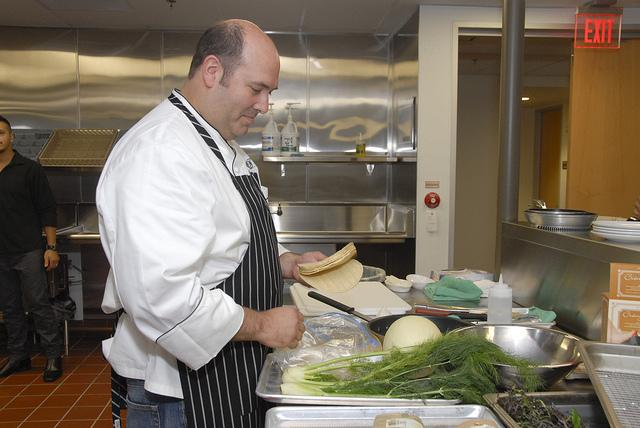What type of wrapper is he putting food in? Please explain your reasoning. tortilla. The other options don't apply to what he's holding in his hand. 